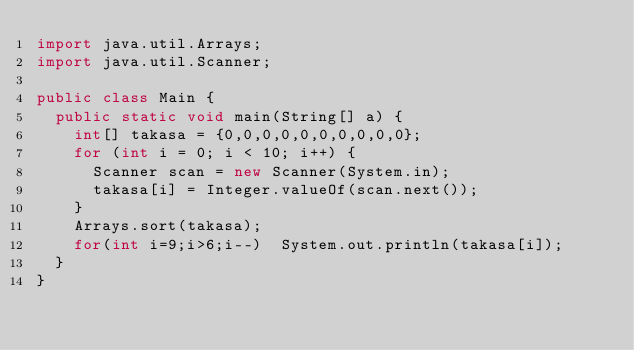<code> <loc_0><loc_0><loc_500><loc_500><_Java_>import java.util.Arrays;
import java.util.Scanner;

public class Main {
	public static void main(String[] a) {
		int[] takasa = {0,0,0,0,0,0,0,0,0,0};
		for (int i = 0; i < 10; i++) {
			Scanner scan = new Scanner(System.in);
			takasa[i] = Integer.valueOf(scan.next());
		}
		Arrays.sort(takasa);
		for(int i=9;i>6;i--)	System.out.println(takasa[i]);
	}
}</code> 